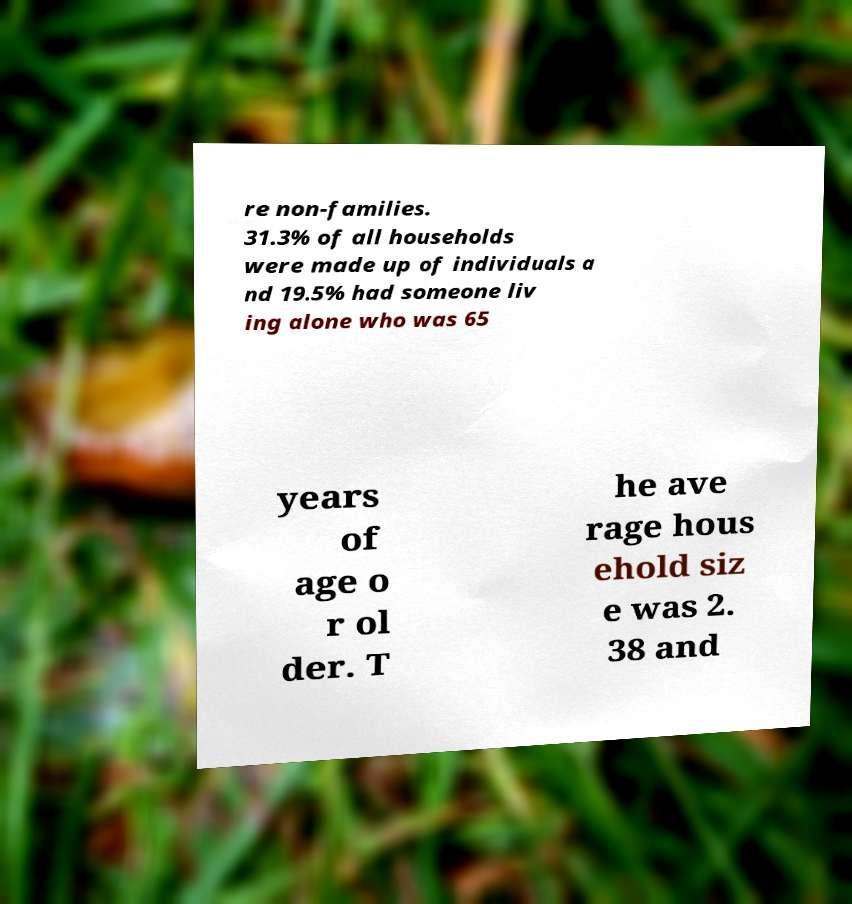Could you extract and type out the text from this image? re non-families. 31.3% of all households were made up of individuals a nd 19.5% had someone liv ing alone who was 65 years of age o r ol der. T he ave rage hous ehold siz e was 2. 38 and 